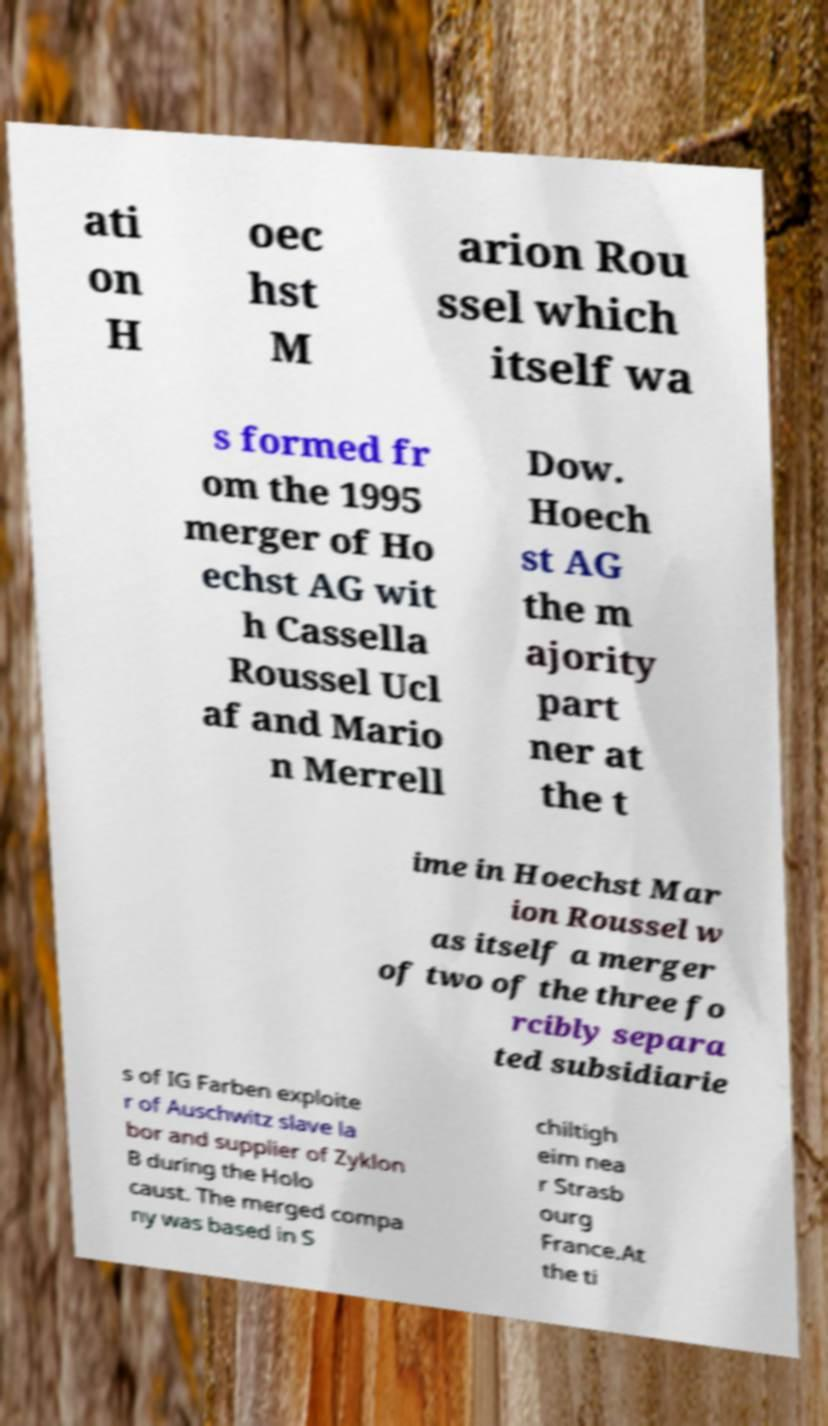What messages or text are displayed in this image? I need them in a readable, typed format. ati on H oec hst M arion Rou ssel which itself wa s formed fr om the 1995 merger of Ho echst AG wit h Cassella Roussel Ucl af and Mario n Merrell Dow. Hoech st AG the m ajority part ner at the t ime in Hoechst Mar ion Roussel w as itself a merger of two of the three fo rcibly separa ted subsidiarie s of IG Farben exploite r of Auschwitz slave la bor and supplier of Zyklon B during the Holo caust. The merged compa ny was based in S chiltigh eim nea r Strasb ourg France.At the ti 